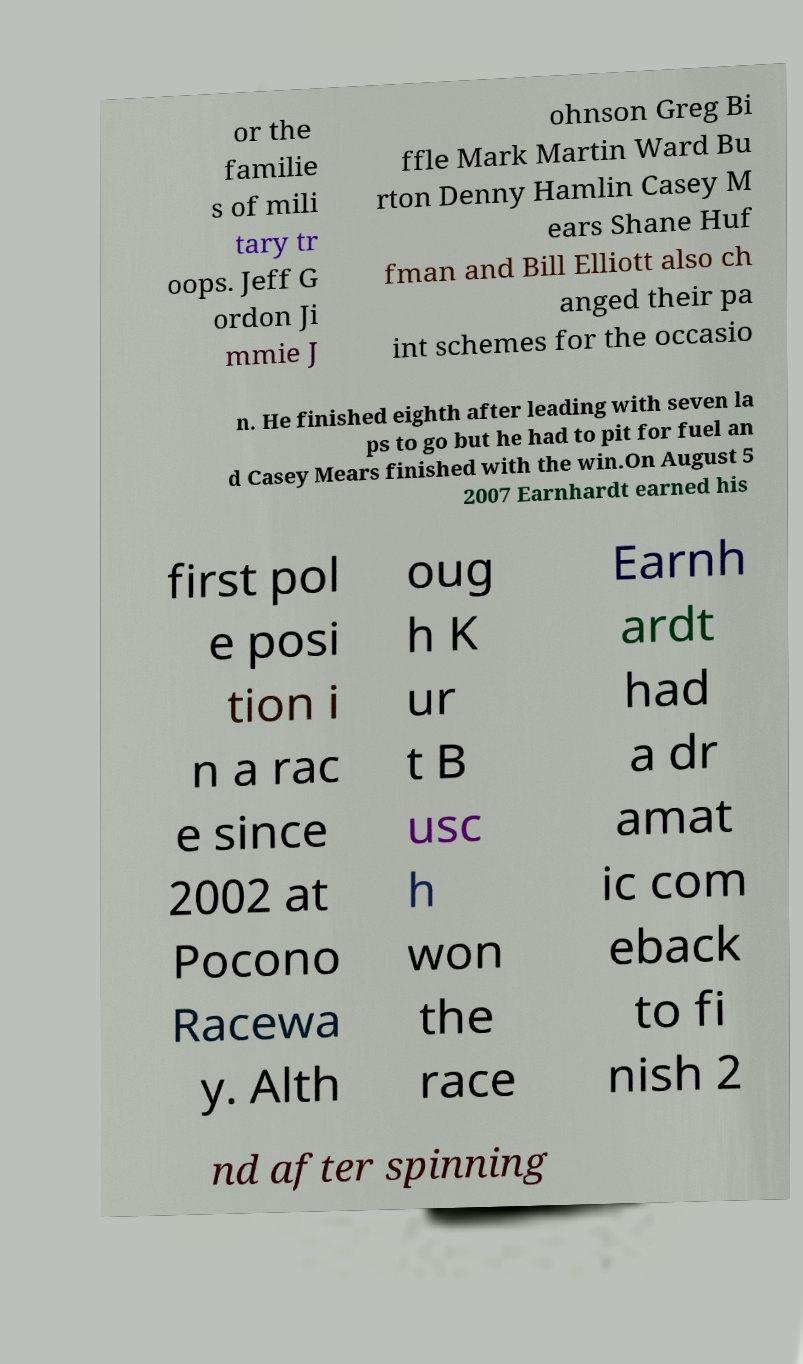Could you assist in decoding the text presented in this image and type it out clearly? or the familie s of mili tary tr oops. Jeff G ordon Ji mmie J ohnson Greg Bi ffle Mark Martin Ward Bu rton Denny Hamlin Casey M ears Shane Huf fman and Bill Elliott also ch anged their pa int schemes for the occasio n. He finished eighth after leading with seven la ps to go but he had to pit for fuel an d Casey Mears finished with the win.On August 5 2007 Earnhardt earned his first pol e posi tion i n a rac e since 2002 at Pocono Racewa y. Alth oug h K ur t B usc h won the race Earnh ardt had a dr amat ic com eback to fi nish 2 nd after spinning 